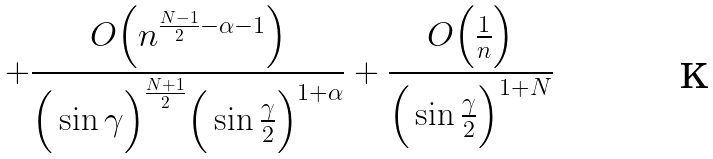Convert formula to latex. <formula><loc_0><loc_0><loc_500><loc_500>+ \frac { O \Big { ( } n ^ { \frac { N - 1 } { 2 } - \alpha - 1 } \Big { ) } } { \Big { ( } \sin \gamma \Big { ) } ^ { \frac { N + 1 } { 2 } } \Big { ( } \sin \frac { \gamma } { 2 } \Big { ) } ^ { 1 + \alpha } } + \frac { O \Big { ( } \frac { 1 } { n } \Big { ) } } { \Big { ( } \sin \frac { \gamma } { 2 } \Big { ) } ^ { 1 + N } }</formula> 